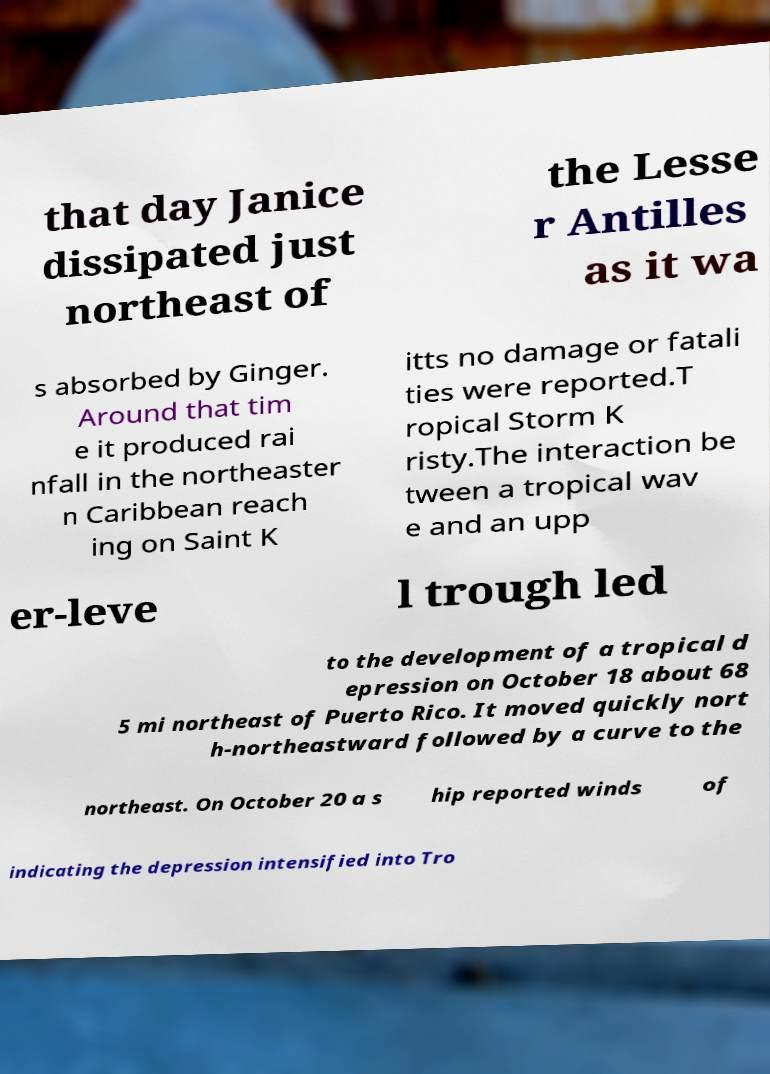Can you accurately transcribe the text from the provided image for me? that day Janice dissipated just northeast of the Lesse r Antilles as it wa s absorbed by Ginger. Around that tim e it produced rai nfall in the northeaster n Caribbean reach ing on Saint K itts no damage or fatali ties were reported.T ropical Storm K risty.The interaction be tween a tropical wav e and an upp er-leve l trough led to the development of a tropical d epression on October 18 about 68 5 mi northeast of Puerto Rico. It moved quickly nort h-northeastward followed by a curve to the northeast. On October 20 a s hip reported winds of indicating the depression intensified into Tro 